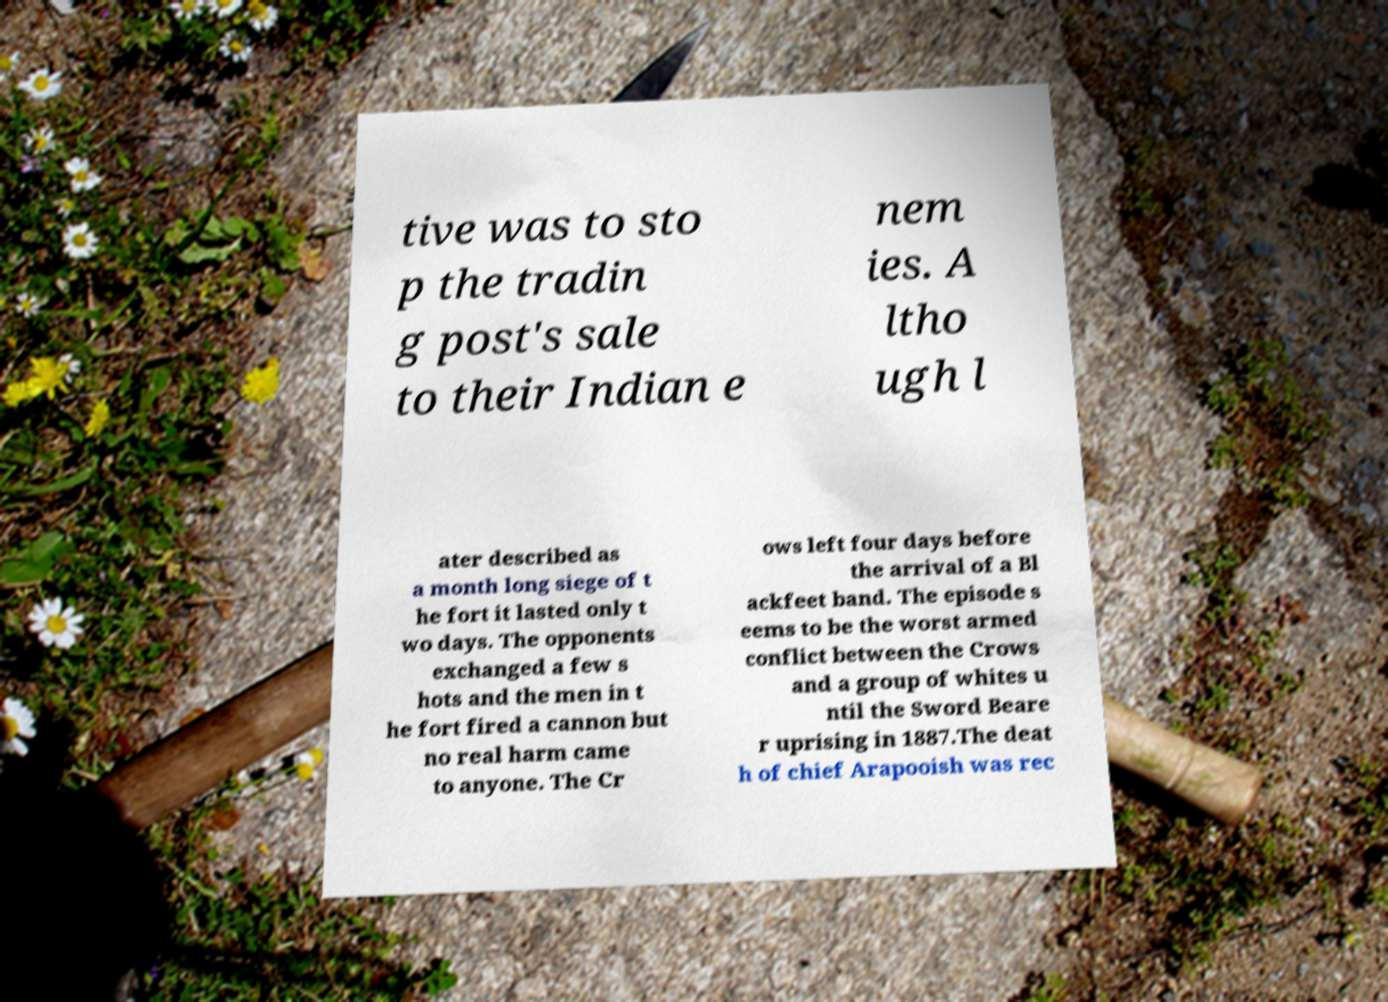Could you extract and type out the text from this image? tive was to sto p the tradin g post's sale to their Indian e nem ies. A ltho ugh l ater described as a month long siege of t he fort it lasted only t wo days. The opponents exchanged a few s hots and the men in t he fort fired a cannon but no real harm came to anyone. The Cr ows left four days before the arrival of a Bl ackfeet band. The episode s eems to be the worst armed conflict between the Crows and a group of whites u ntil the Sword Beare r uprising in 1887.The deat h of chief Arapooish was rec 